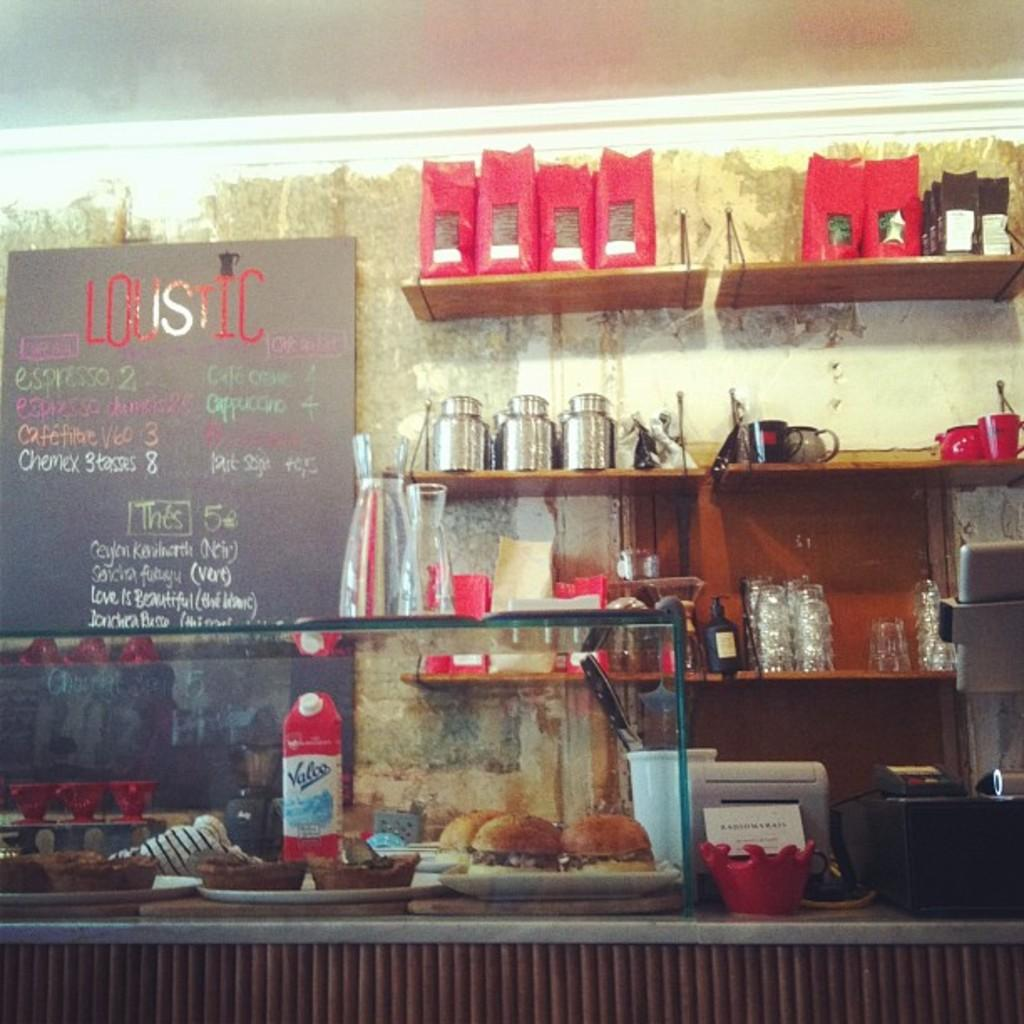<image>
Offer a succinct explanation of the picture presented. Restaraunt menu board with the name of Lousticat the top. 